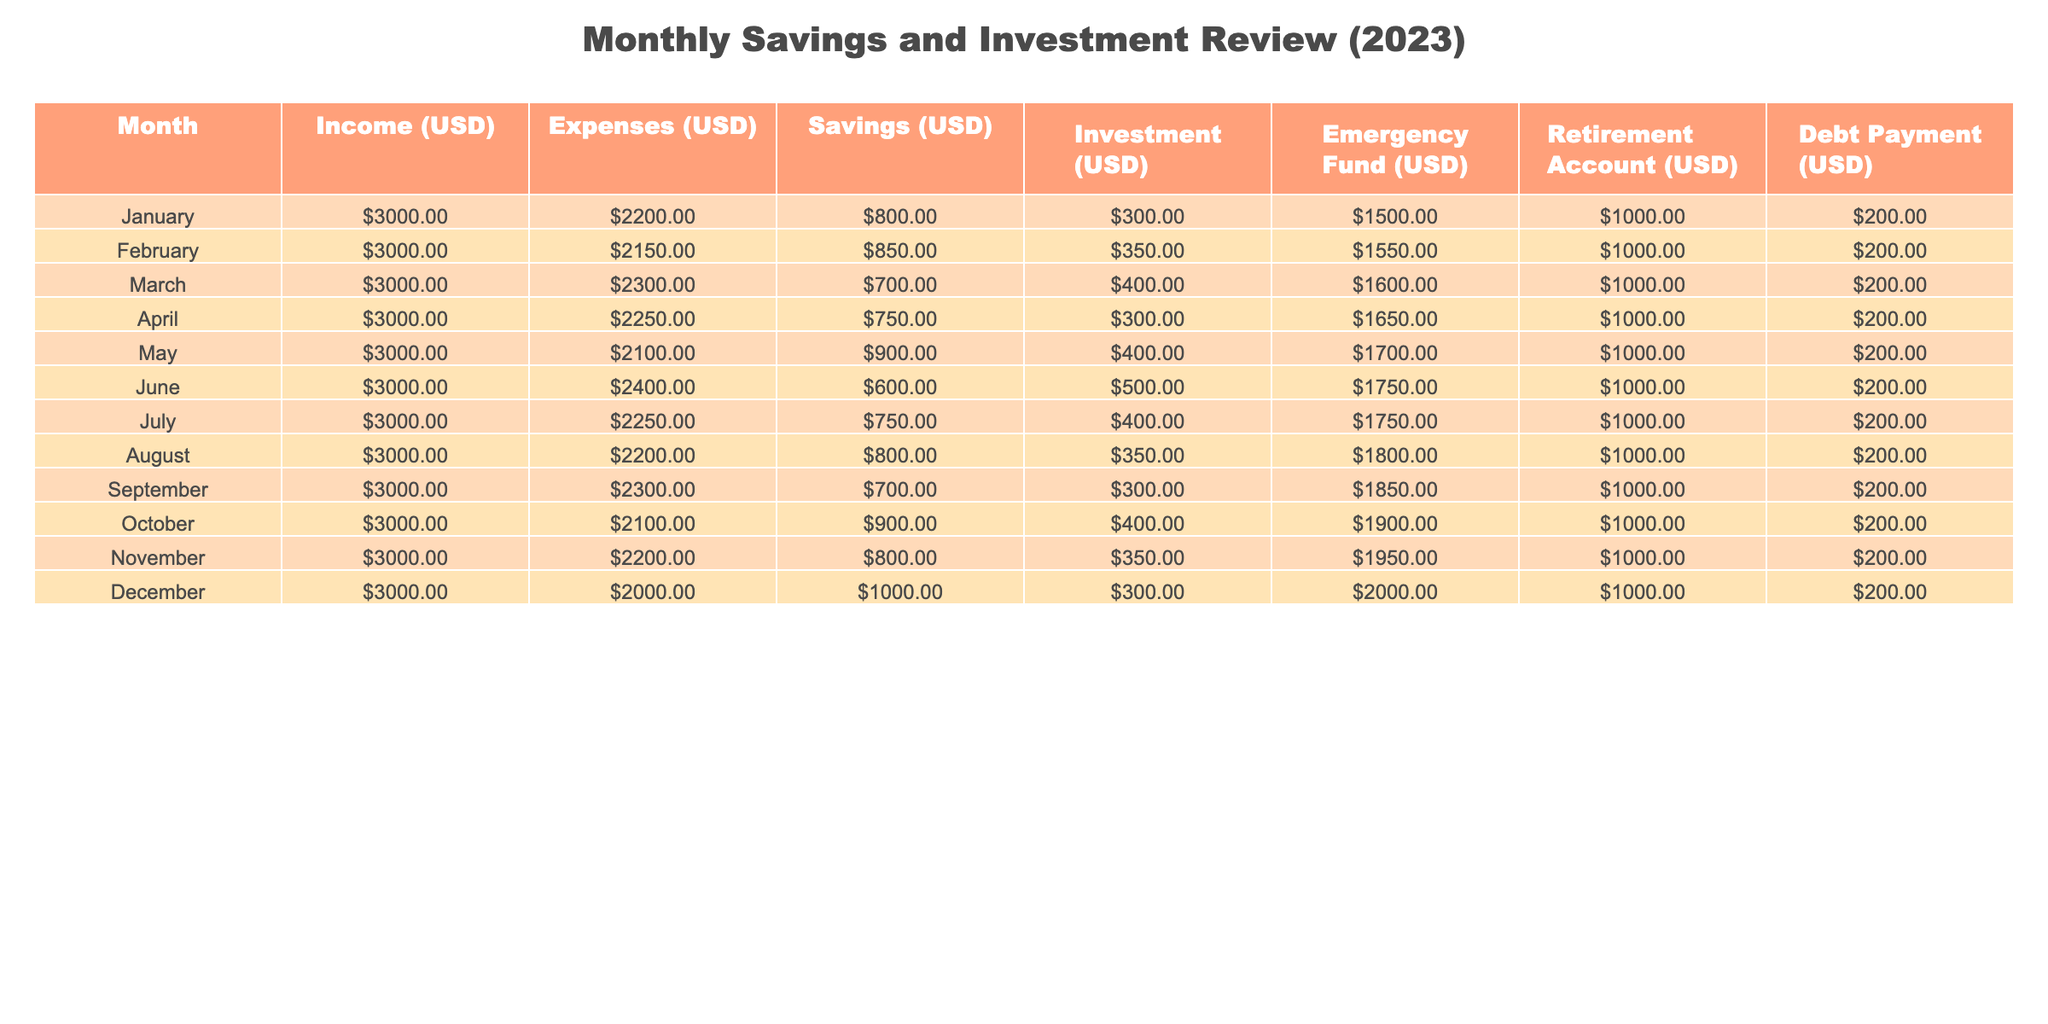What was the total income in April? The income for April is listed as USD 3000 in the table.
Answer: 3000 Which month had the highest savings? By comparing the savings across all months, December shows the highest savings amount of USD 1000.
Answer: December What is the average amount spent on expenses over the year? To find the average, sum all monthly expenses (2200 + 2150 + 2300 + 2250 + 2100 + 2400 + 2250 + 2200 + 2300 + 2100 + 2200 + 2000 = 26300) and divide by 12, resulting in an average of USD 2191.67.
Answer: 2191.67 Did the savings increase from January to December? In January, the savings were USD 800, and in December, they increased to USD 1000, indicating that savings did indeed increase over the year.
Answer: Yes What was the total investment made in the first half of the year (January to June)? Adding the investment amounts: (300 + 350 + 400 + 300 + 400 + 500) gives a total of USD 2250 in investments for the first half of the year.
Answer: 2250 What percentage of total income in May was saved? In May, the income was USD 3000, and savings were USD 900. The percentage saved is (900/3000) * 100 = 30%.
Answer: 30% Was there a month where expenses were lower than the previous month? After examining expenses month by month, January (2200) to February (2150) shows a decrease, confirming that there was indeed a month with lower expenses.
Answer: Yes What is the difference in the amount allocated to the emergency fund between January and December? The emergency fund in January was USD 1500, and in December it was USD 2000. The difference is USD 2000 - 1500 = USD 500.
Answer: 500 How much total debt payment was made by the end of the year? Since the debt payment was constant at USD 200 each month, the total for 12 months is USD 200 * 12 = USD 2400.
Answer: 2400 Which month had the lowest investment amount, and what was it? Assessing the investments for each month, March has the lowest investment at USD 400.
Answer: March, 400 During which month was the lowest savings recorded, and how much was it? March showed the lowest savings at USD 700 when reviewed against the savings for all months.
Answer: March, 700 